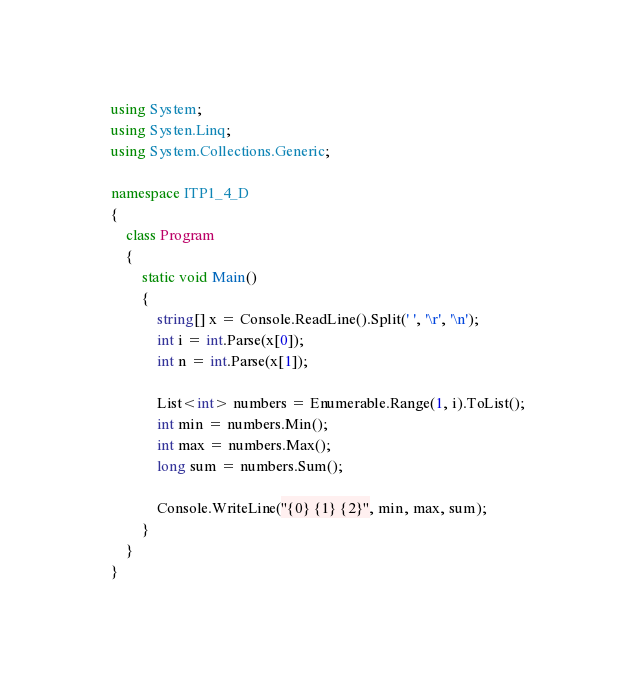<code> <loc_0><loc_0><loc_500><loc_500><_C#_>using System;
using Systen.Linq;
using System.Collections.Generic;

namespace ITP1_4_D
{
    class Program
    {
        static void Main()
        {
            string[] x = Console.ReadLine().Split(' ', '\r', '\n');
            int i = int.Parse(x[0]);
            int n = int.Parse(x[1]);
            
            List<int> numbers = Enumerable.Range(1, i).ToList();
            int min = numbers.Min();
            int max = numbers.Max();
            long sum = numbers.Sum();
            
            Console.WriteLine("{0} {1} {2}", min, max, sum);
        }
    }
}
</code> 